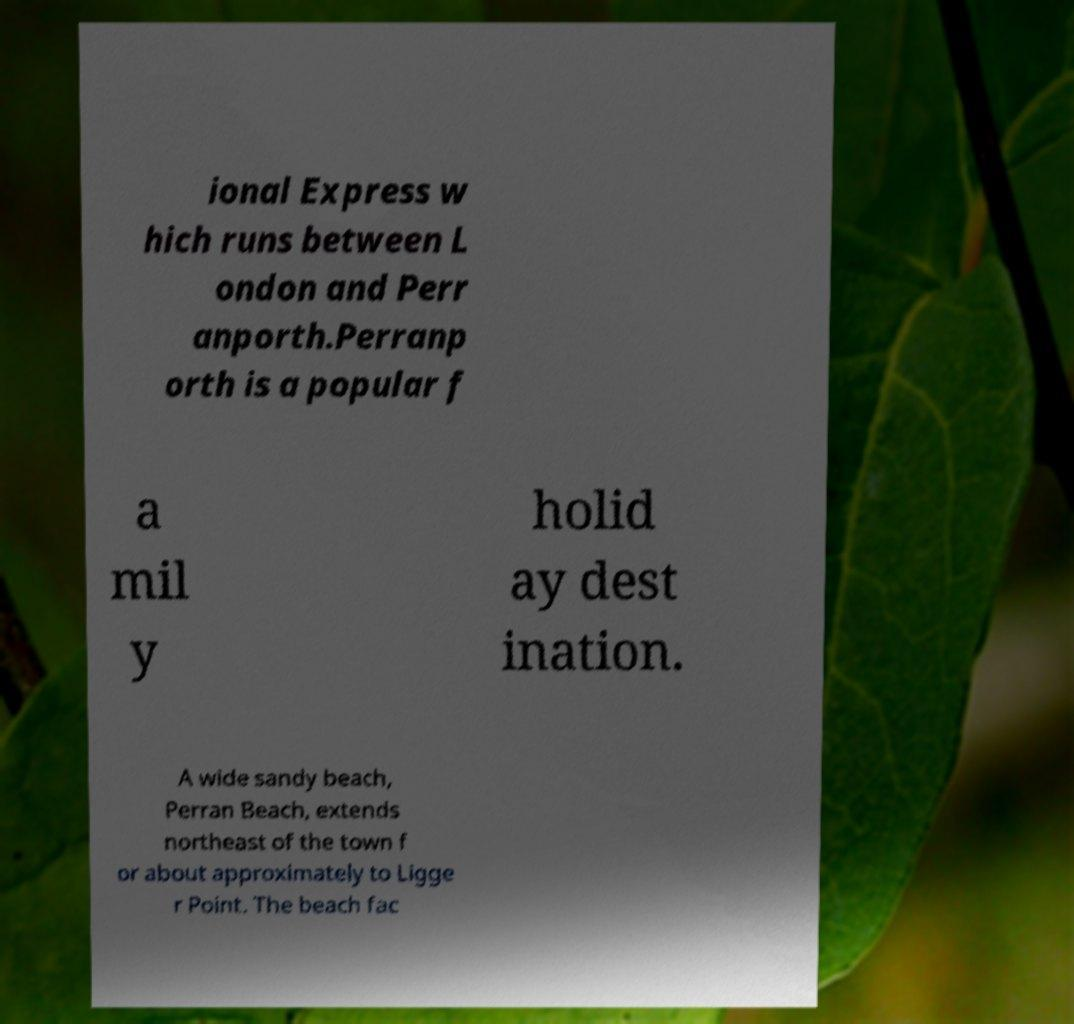Could you extract and type out the text from this image? ional Express w hich runs between L ondon and Perr anporth.Perranp orth is a popular f a mil y holid ay dest ination. A wide sandy beach, Perran Beach, extends northeast of the town f or about approximately to Ligge r Point. The beach fac 